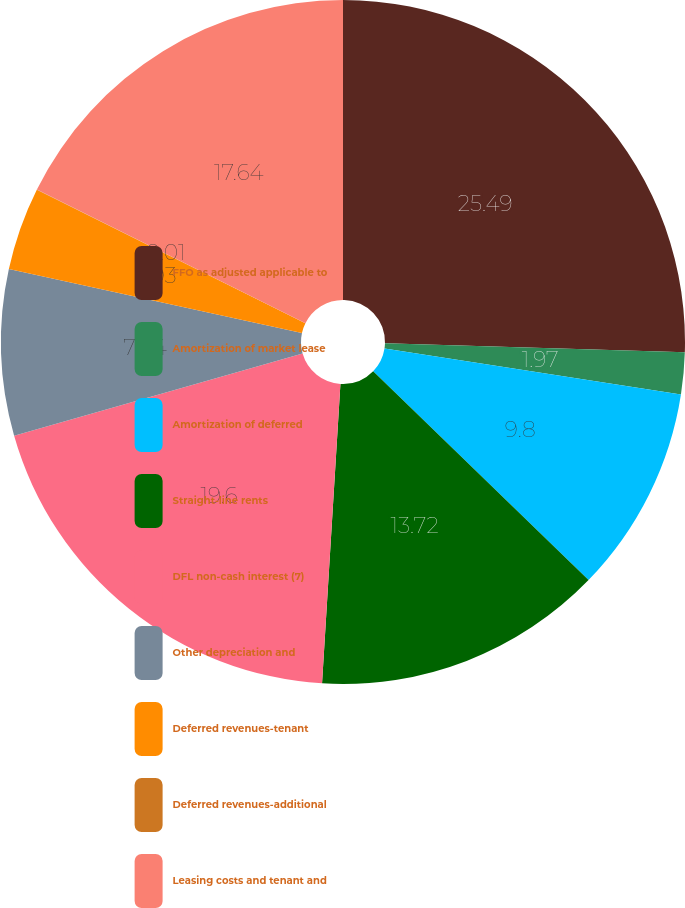<chart> <loc_0><loc_0><loc_500><loc_500><pie_chart><fcel>FFO as adjusted applicable to<fcel>Amortization of market lease<fcel>Amortization of deferred<fcel>Straight-line rents<fcel>DFL non-cash interest (7)<fcel>Other depreciation and<fcel>Deferred revenues-tenant<fcel>Deferred revenues-additional<fcel>Leasing costs and tenant and<nl><fcel>25.48%<fcel>1.97%<fcel>9.8%<fcel>13.72%<fcel>19.6%<fcel>7.84%<fcel>3.93%<fcel>0.01%<fcel>17.64%<nl></chart> 